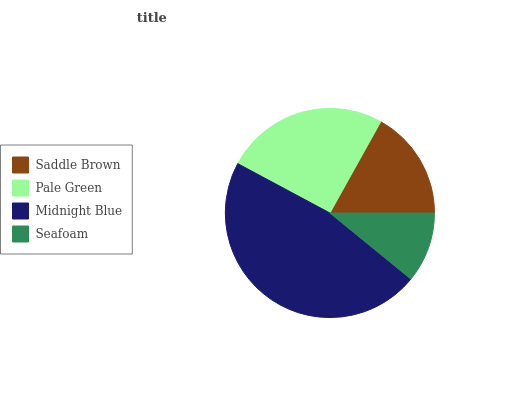Is Seafoam the minimum?
Answer yes or no. Yes. Is Midnight Blue the maximum?
Answer yes or no. Yes. Is Pale Green the minimum?
Answer yes or no. No. Is Pale Green the maximum?
Answer yes or no. No. Is Pale Green greater than Saddle Brown?
Answer yes or no. Yes. Is Saddle Brown less than Pale Green?
Answer yes or no. Yes. Is Saddle Brown greater than Pale Green?
Answer yes or no. No. Is Pale Green less than Saddle Brown?
Answer yes or no. No. Is Pale Green the high median?
Answer yes or no. Yes. Is Saddle Brown the low median?
Answer yes or no. Yes. Is Midnight Blue the high median?
Answer yes or no. No. Is Midnight Blue the low median?
Answer yes or no. No. 